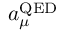<formula> <loc_0><loc_0><loc_500><loc_500>a _ { \mu } ^ { Q E D }</formula> 